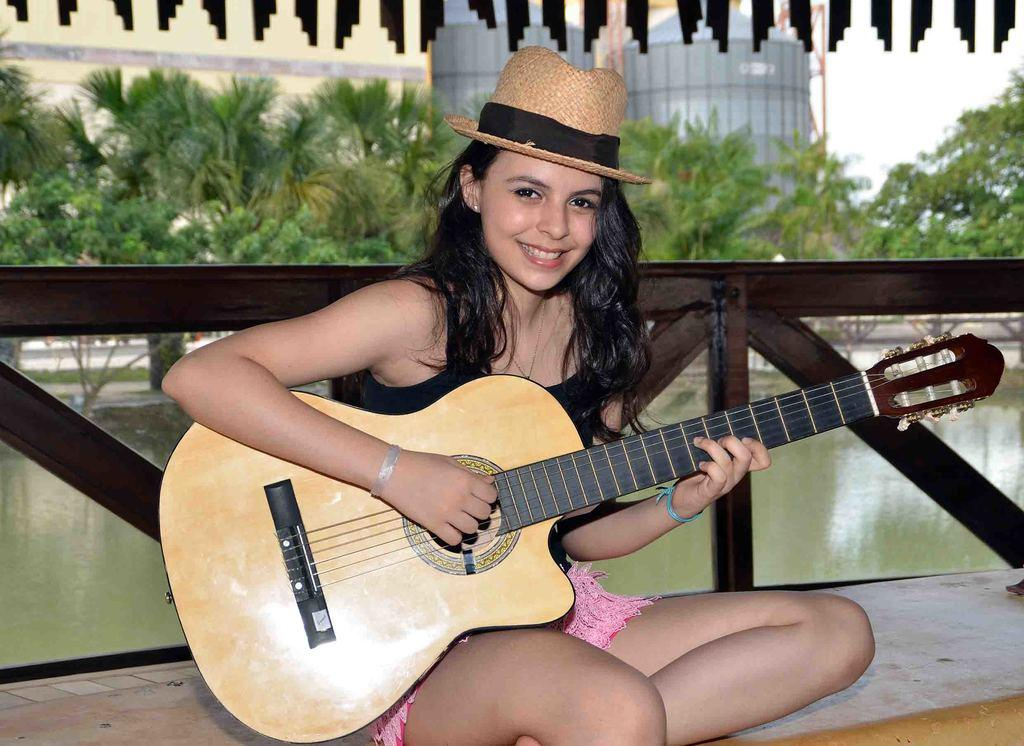What is the main subject of the image? The main subject of the image is a woman. What is the woman doing in the image? The woman is sitting and holding a guitar. What is the woman's facial expression in the image? The woman is smiling. What can be seen in the background of the image? Water, trees, and buildings are visible in the background of the image. How many sheep are visible in the image? There are no sheep present in the image. What type of cent is the woman using to play the guitar in the image? There is no cent involved in playing the guitar in the image; the woman is simply holding and presumably playing the guitar. 